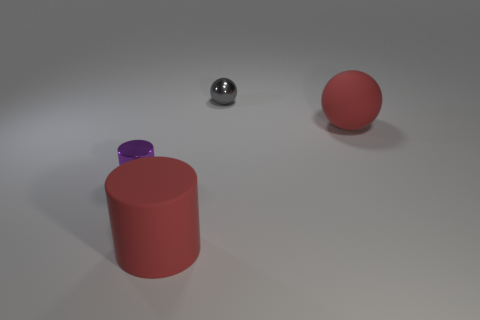Add 4 big cyan metal cubes. How many objects exist? 8 Add 4 spheres. How many spheres are left? 6 Add 1 purple cylinders. How many purple cylinders exist? 2 Subtract 0 green cylinders. How many objects are left? 4 Subtract all blue objects. Subtract all tiny metal balls. How many objects are left? 3 